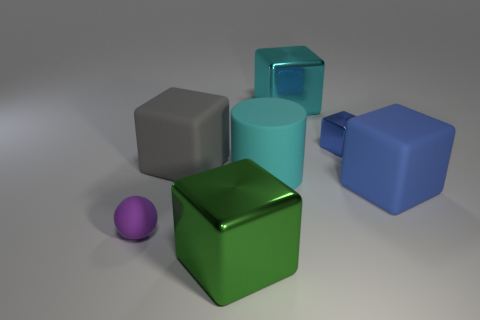There is a large green thing that is the same shape as the blue matte thing; what is its material?
Offer a terse response. Metal. What color is the small object that is behind the big blue matte thing?
Provide a succinct answer. Blue. What size is the purple object?
Offer a terse response. Small. Does the purple object have the same size as the shiny block in front of the small purple ball?
Offer a very short reply. No. There is a large object that is on the right side of the big block that is behind the tiny thing to the right of the large cyan rubber cylinder; what is its color?
Your response must be concise. Blue. Is the tiny thing that is to the right of the large green metallic block made of the same material as the large cyan cylinder?
Offer a terse response. No. How many other things are the same material as the big gray block?
Keep it short and to the point. 3. There is a green block that is the same size as the cyan metallic object; what is its material?
Your response must be concise. Metal. There is a large object right of the small metallic block; is it the same shape as the large shiny thing behind the purple thing?
Offer a very short reply. Yes. There is a cyan metallic object that is the same size as the gray matte cube; what is its shape?
Provide a succinct answer. Cube. 